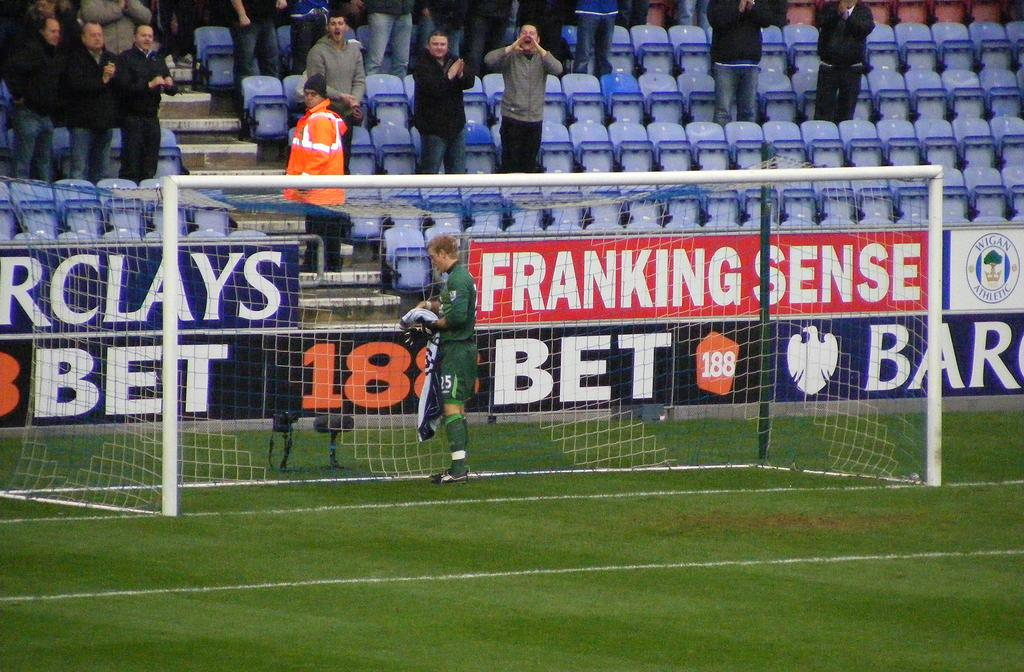<image>
Describe the image concisely. A goalie in the goal with a banner reading Franking Sense behind him. 